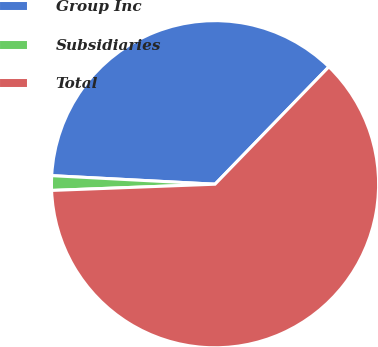<chart> <loc_0><loc_0><loc_500><loc_500><pie_chart><fcel>Group Inc<fcel>Subsidiaries<fcel>Total<nl><fcel>36.42%<fcel>1.44%<fcel>62.14%<nl></chart> 